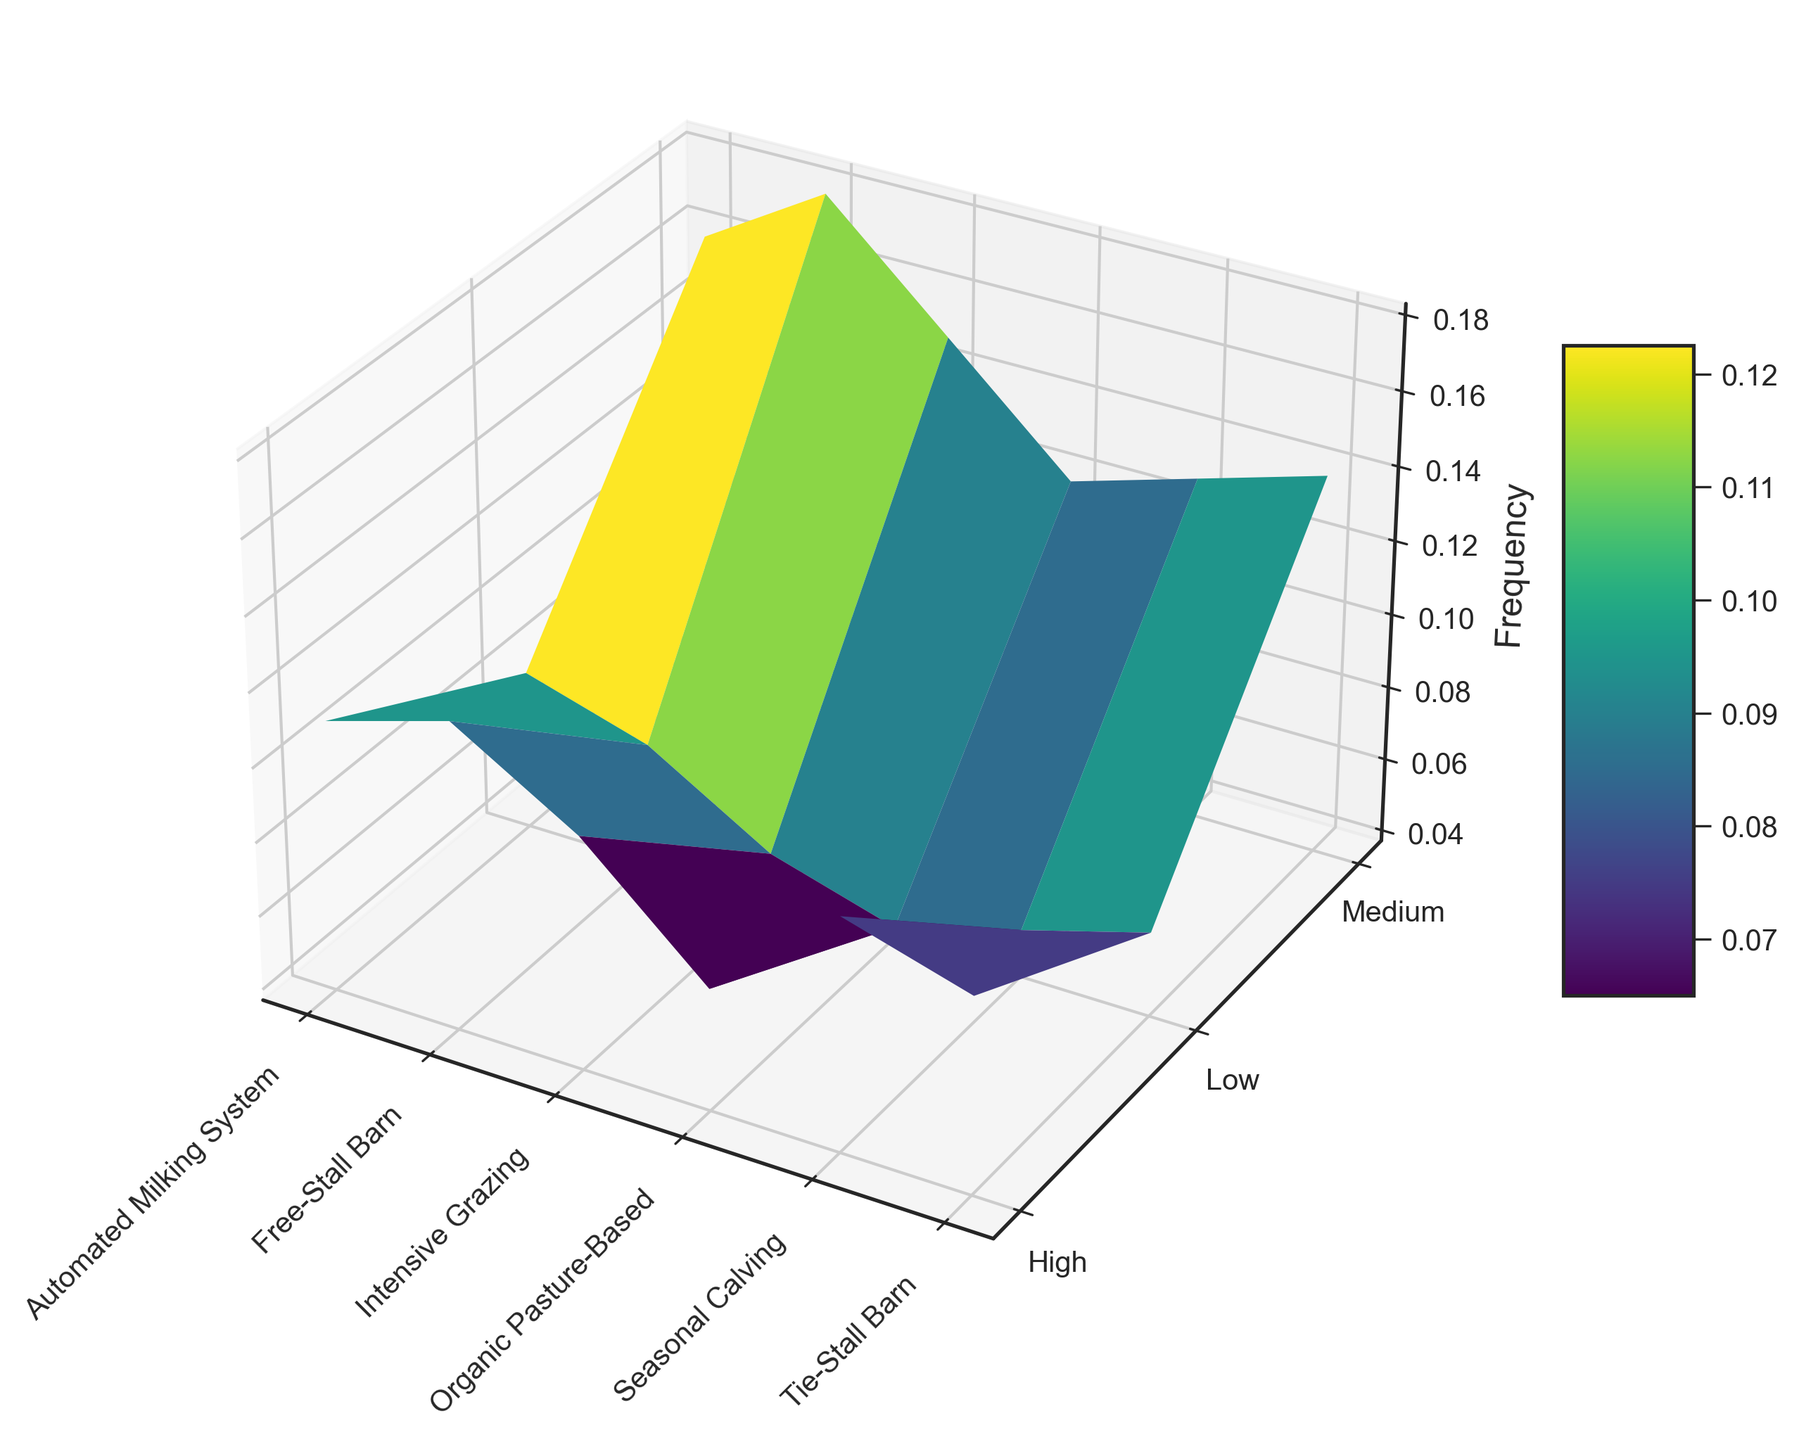What is the frequency of medium severity mastitis in the Free-Stall Barn system? Look at the medium severity data point for the Free-Stall Barn system and read the corresponding frequency value.
Answer: 0.18 Which herd management system has the highest frequency of low severity mastitis? Compare the frequencies of low severity mastitis across all herd management systems and identify the highest value.
Answer: Automated Milking System Between Organic Pasture-Based and Intensive Grazing, which system has a higher frequency of high severity mastitis? Compare the frequencies of high severity mastitis between the Organic Pasture-Based and Intensive Grazing systems and determine which is greater.
Answer: Intensive Grazing What is the average frequency of medium severity mastitis across all herd management systems? Sum the frequencies of medium severity mastitis for all herd management systems and divide by the number of systems: (0.15 + 0.18 + 0.14 + 0.12 + 0.16 + 0.13) / 6.
Answer: 0.15 Which severity level shows the most significant variation in frequency across different herd management systems? Compare the range of frequencies for low, medium, and high severity levels across all systems. The most significant variation is observed if the difference between the highest and lowest values is the largest for that severity level. Medium: 0.18 - 0.12 = 0.06, Low: 0.08 - 0.04 = 0.04, High: 0.12 - 0.07 = 0.05.
Answer: Medium severity How does the frequency of low severity mastitis in the Tie-Stall Barn compare to that in the Seasonal Calving system? Look at the data points for low severity mastitis frequencies in Tie-Stall Barn and Seasonal Calving, then compare them.
Answer: Tie-Stall Barn is higher (0.06 vs. 0.05) For which herd management system is the difference between the frequencies of high and low severity mastitis the smallest? Calculate the differences between high and low severity frequencies for each system and find the smallest value: Intensive Grazing: 0.10 - 0.05 = 0.05, Free-Stall Barn: 0.12 - 0.07 = 0.05, Tie-Stall Barn: 0.09 - 0.06 = 0.03, Organic Pasture-Based: 0.07 - 0.04 = 0.03, Automated Milking System: 0.11 - 0.08 = 0.03, Seasonal Calving: 0.10 - 0.05 = 0.05.
Answer: Tie-Stall Barn, Organic Pasture-Based, Automated Milking System (tie) What does the color gradient in the plot indicate? The color gradient indicates the frequency of mastitis across different herd management systems, with different colors representing different frequency levels. Darker regions denote higher frequencies, whereas lighter regions denote lower frequencies.
Answer: Frequency levels 